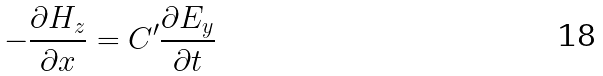<formula> <loc_0><loc_0><loc_500><loc_500>- \frac { \partial H _ { z } } { \partial x } = C ^ { \prime } \frac { \partial E _ { y } } { \partial t }</formula> 